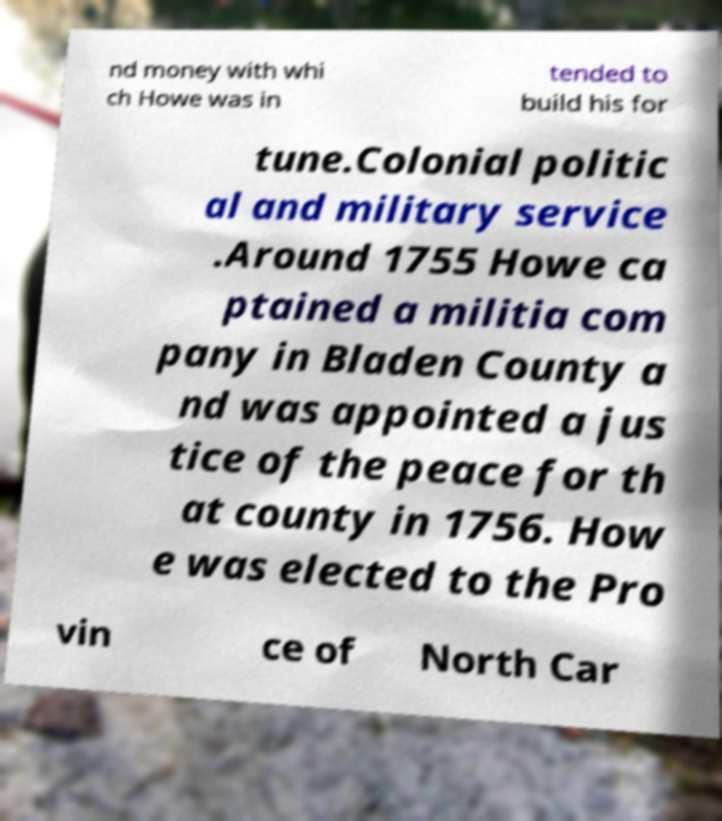Can you accurately transcribe the text from the provided image for me? nd money with whi ch Howe was in tended to build his for tune.Colonial politic al and military service .Around 1755 Howe ca ptained a militia com pany in Bladen County a nd was appointed a jus tice of the peace for th at county in 1756. How e was elected to the Pro vin ce of North Car 